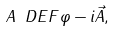<formula> <loc_0><loc_0><loc_500><loc_500>A \ D E F \varphi - i \vec { A } ,</formula> 